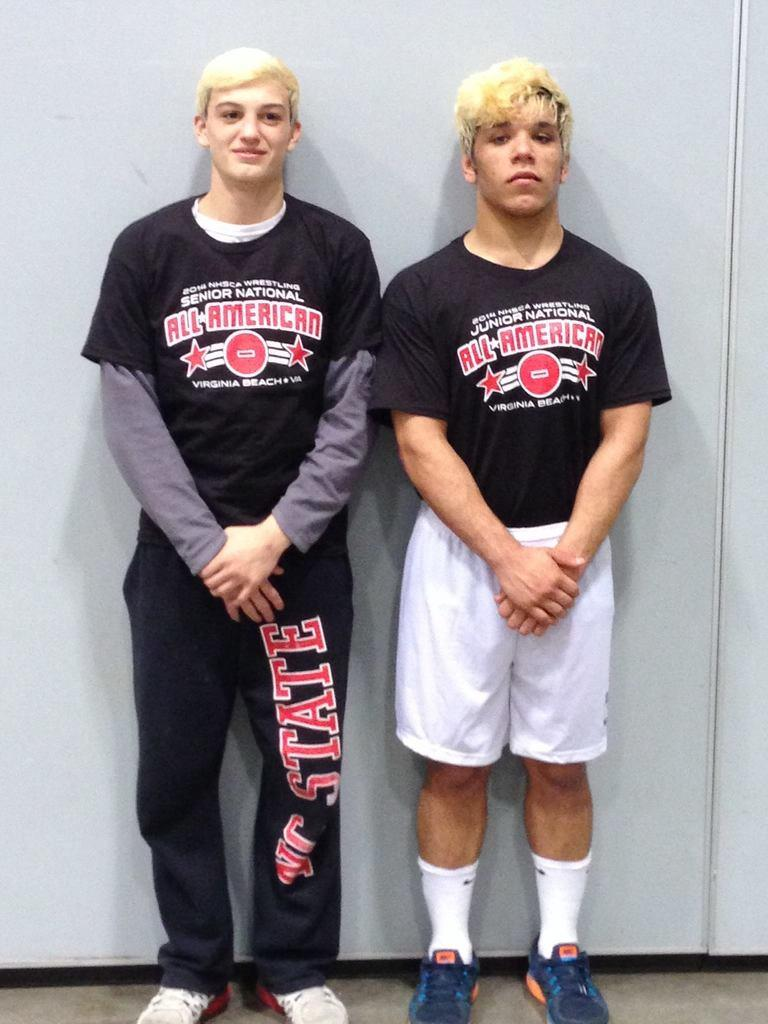Provide a one-sentence caption for the provided image. 2 men are wearing shirts that say all american. 